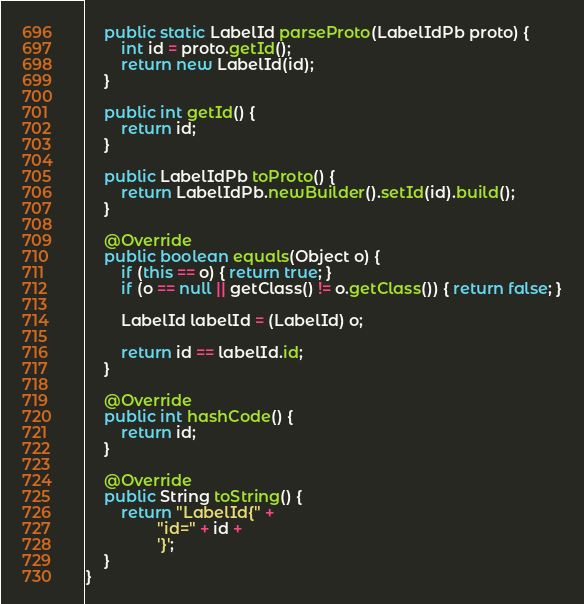Convert code to text. <code><loc_0><loc_0><loc_500><loc_500><_Java_>    public static LabelId parseProto(LabelIdPb proto) {
        int id = proto.getId();
        return new LabelId(id);
    }

    public int getId() {
        return id;
    }

    public LabelIdPb toProto() {
        return LabelIdPb.newBuilder().setId(id).build();
    }

    @Override
    public boolean equals(Object o) {
        if (this == o) { return true; }
        if (o == null || getClass() != o.getClass()) { return false; }

        LabelId labelId = (LabelId) o;

        return id == labelId.id;
    }

    @Override
    public int hashCode() {
        return id;
    }

    @Override
    public String toString() {
        return "LabelId{" +
                "id=" + id +
                '}';
    }
}
</code> 